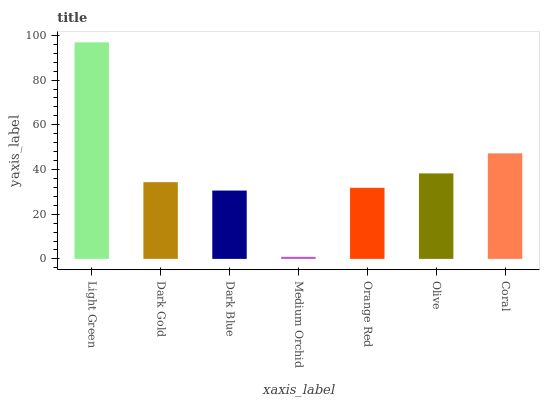Is Medium Orchid the minimum?
Answer yes or no. Yes. Is Light Green the maximum?
Answer yes or no. Yes. Is Dark Gold the minimum?
Answer yes or no. No. Is Dark Gold the maximum?
Answer yes or no. No. Is Light Green greater than Dark Gold?
Answer yes or no. Yes. Is Dark Gold less than Light Green?
Answer yes or no. Yes. Is Dark Gold greater than Light Green?
Answer yes or no. No. Is Light Green less than Dark Gold?
Answer yes or no. No. Is Dark Gold the high median?
Answer yes or no. Yes. Is Dark Gold the low median?
Answer yes or no. Yes. Is Olive the high median?
Answer yes or no. No. Is Light Green the low median?
Answer yes or no. No. 